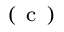Convert formula to latex. <formula><loc_0><loc_0><loc_500><loc_500>^ { ( } c )</formula> 